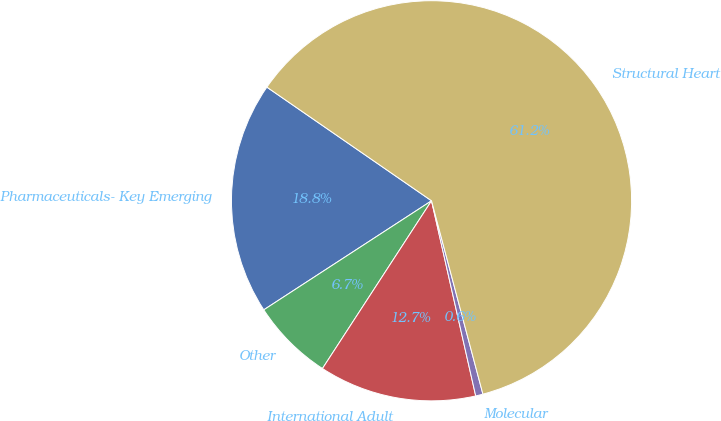<chart> <loc_0><loc_0><loc_500><loc_500><pie_chart><fcel>Pharmaceuticals- Key Emerging<fcel>Other<fcel>International Adult<fcel>Molecular<fcel>Structural Heart<nl><fcel>18.79%<fcel>6.65%<fcel>12.72%<fcel>0.59%<fcel>61.25%<nl></chart> 